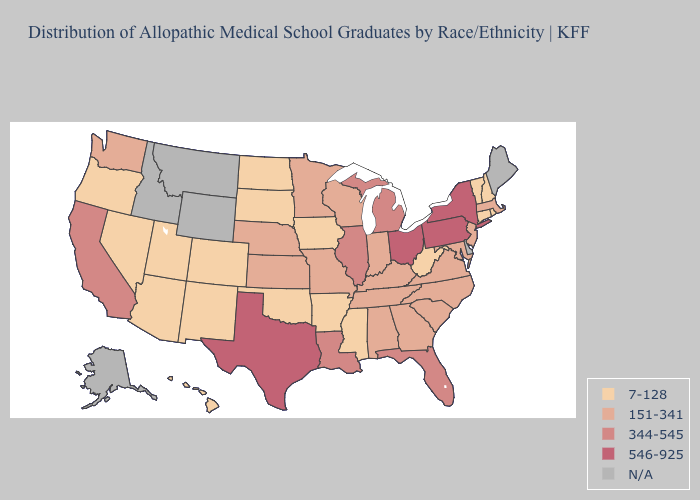Does the map have missing data?
Quick response, please. Yes. Does Ohio have the highest value in the MidWest?
Be succinct. Yes. Does Florida have the highest value in the USA?
Concise answer only. No. How many symbols are there in the legend?
Quick response, please. 5. Name the states that have a value in the range 546-925?
Be succinct. New York, Ohio, Pennsylvania, Texas. What is the highest value in the MidWest ?
Keep it brief. 546-925. What is the lowest value in states that border Tennessee?
Short answer required. 7-128. What is the value of Wisconsin?
Quick response, please. 151-341. What is the value of California?
Be succinct. 344-545. Which states have the lowest value in the South?
Be succinct. Arkansas, Mississippi, Oklahoma, West Virginia. Name the states that have a value in the range N/A?
Concise answer only. Alaska, Delaware, Idaho, Maine, Montana, Wyoming. How many symbols are there in the legend?
Answer briefly. 5. Does the map have missing data?
Give a very brief answer. Yes. 